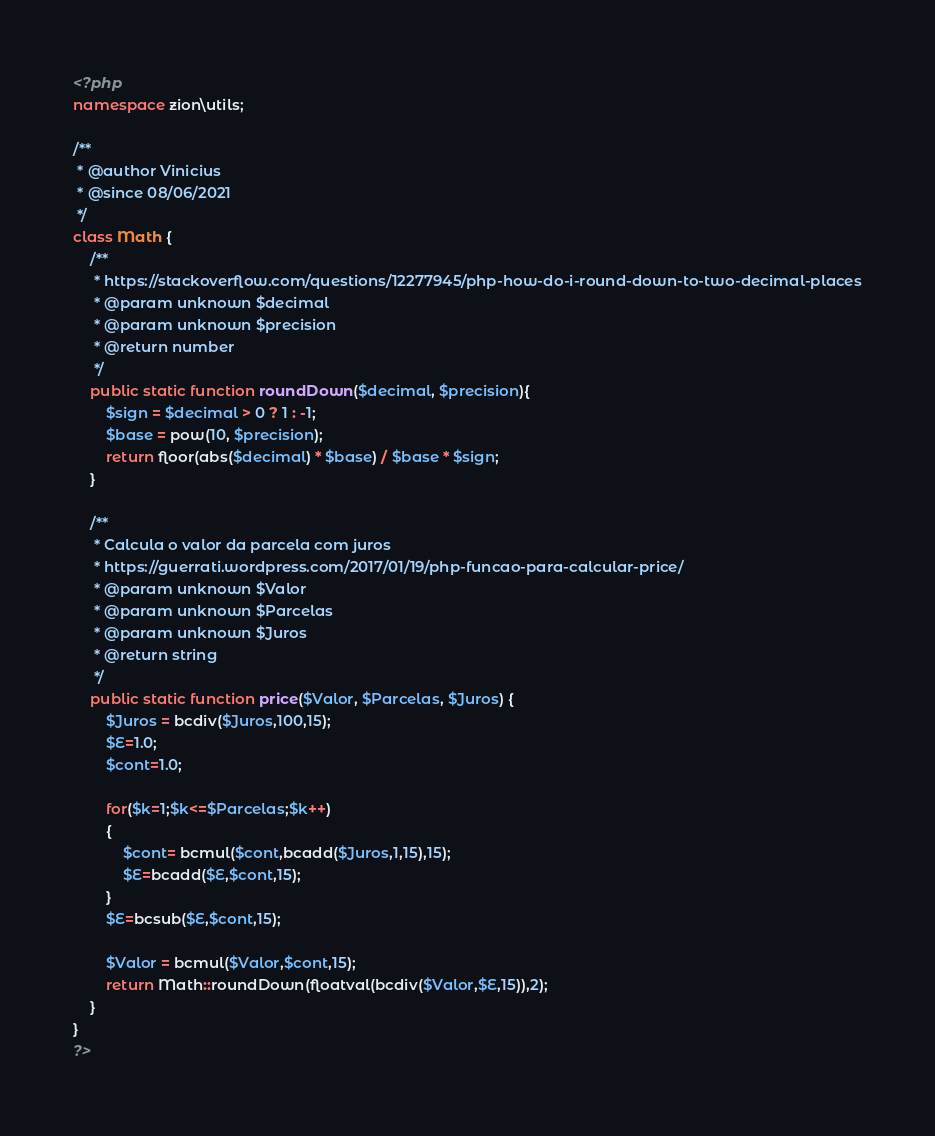<code> <loc_0><loc_0><loc_500><loc_500><_PHP_><?php 
namespace zion\utils;

/**
 * @author Vinicius
 * @since 08/06/2021
 */
class Math {
    /**
     * https://stackoverflow.com/questions/12277945/php-how-do-i-round-down-to-two-decimal-places
     * @param unknown $decimal
     * @param unknown $precision
     * @return number
     */
    public static function roundDown($decimal, $precision){
        $sign = $decimal > 0 ? 1 : -1;
        $base = pow(10, $precision);
        return floor(abs($decimal) * $base) / $base * $sign;
    }
    
    /**
     * Calcula o valor da parcela com juros
     * https://guerrati.wordpress.com/2017/01/19/php-funcao-para-calcular-price/
     * @param unknown $Valor
     * @param unknown $Parcelas
     * @param unknown $Juros
     * @return string
     */
    public static function price($Valor, $Parcelas, $Juros) {
        $Juros = bcdiv($Juros,100,15);
        $E=1.0;
        $cont=1.0;
        
        for($k=1;$k<=$Parcelas;$k++)
        {
            $cont= bcmul($cont,bcadd($Juros,1,15),15);
            $E=bcadd($E,$cont,15);
        }
        $E=bcsub($E,$cont,15);
        
        $Valor = bcmul($Valor,$cont,15);
        return Math::roundDown(floatval(bcdiv($Valor,$E,15)),2);
    }
}
?></code> 